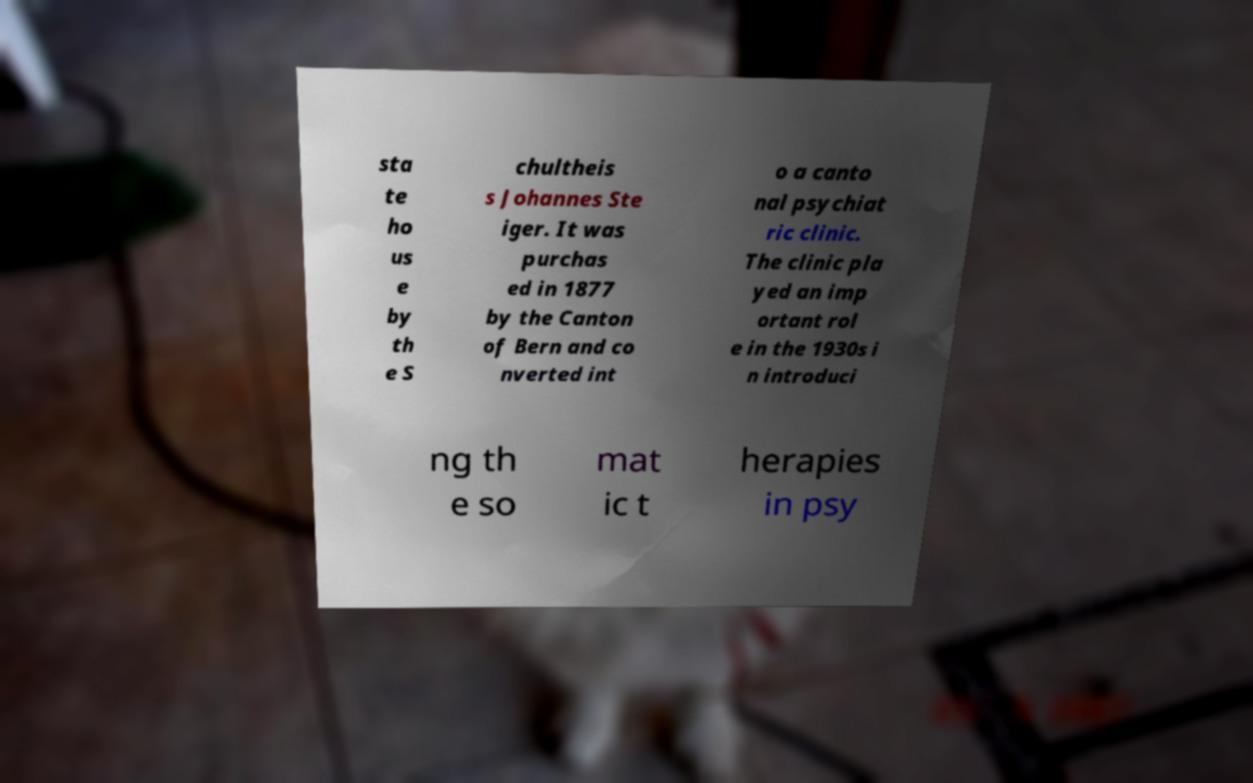Please identify and transcribe the text found in this image. sta te ho us e by th e S chultheis s Johannes Ste iger. It was purchas ed in 1877 by the Canton of Bern and co nverted int o a canto nal psychiat ric clinic. The clinic pla yed an imp ortant rol e in the 1930s i n introduci ng th e so mat ic t herapies in psy 